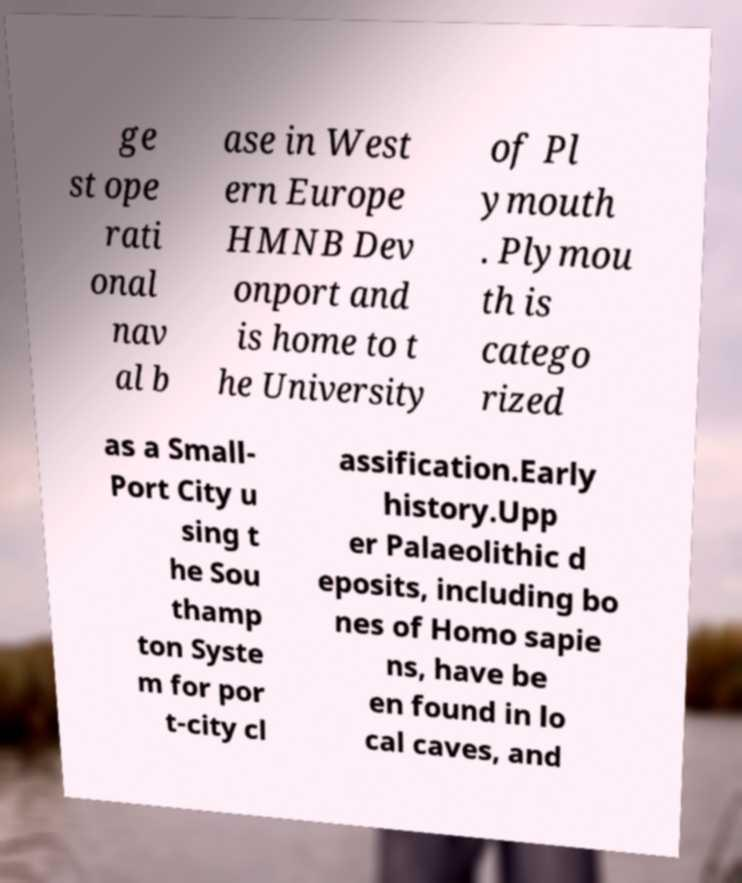What messages or text are displayed in this image? I need them in a readable, typed format. ge st ope rati onal nav al b ase in West ern Europe HMNB Dev onport and is home to t he University of Pl ymouth . Plymou th is catego rized as a Small- Port City u sing t he Sou thamp ton Syste m for por t-city cl assification.Early history.Upp er Palaeolithic d eposits, including bo nes of Homo sapie ns, have be en found in lo cal caves, and 